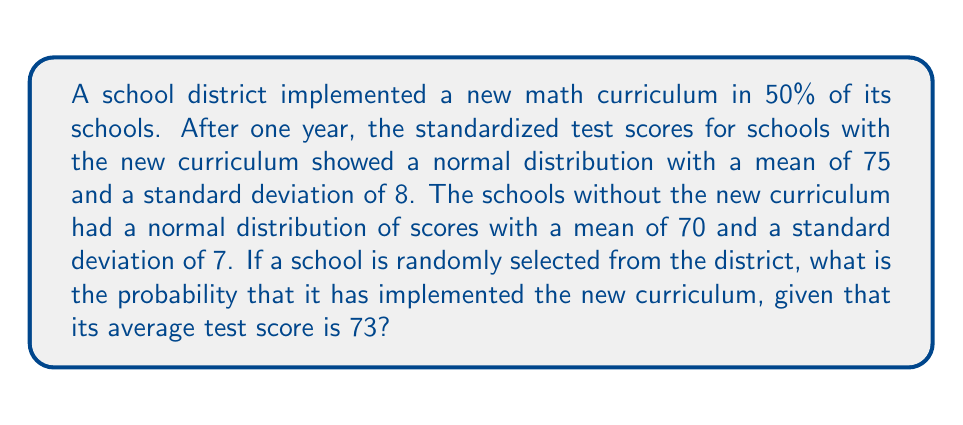Could you help me with this problem? Let's approach this using Bayes' theorem:

1) Define events:
   A: School has implemented the new curriculum
   B: School's average test score is 73

2) We need to find P(A|B). Bayes' theorem states:

   $$P(A|B) = \frac{P(B|A) \cdot P(A)}{P(B)}$$

3) Given information:
   P(A) = 0.5 (50% of schools implemented the new curriculum)
   P(not A) = 0.5

4) Calculate P(B|A):
   For schools with new curriculum: N(μ=75, σ=8)
   Z-score = $\frac{73-75}{8} = -0.25$
   Using standard normal distribution table:
   P(B|A) ≈ 0.3944

5) Calculate P(B|not A):
   For schools without new curriculum: N(μ=70, σ=7)
   Z-score = $\frac{73-70}{7} = 0.4286$
   Using standard normal distribution table:
   P(B|not A) ≈ 0.3336

6) Calculate P(B):
   P(B) = P(B|A) · P(A) + P(B|not A) · P(not A)
        = 0.3944 · 0.5 + 0.3336 · 0.5
        = 0.1972 + 0.1668
        = 0.3640

7) Apply Bayes' theorem:
   $$P(A|B) = \frac{0.3944 \cdot 0.5}{0.3640} \approx 0.5417$$
Answer: 0.5417 